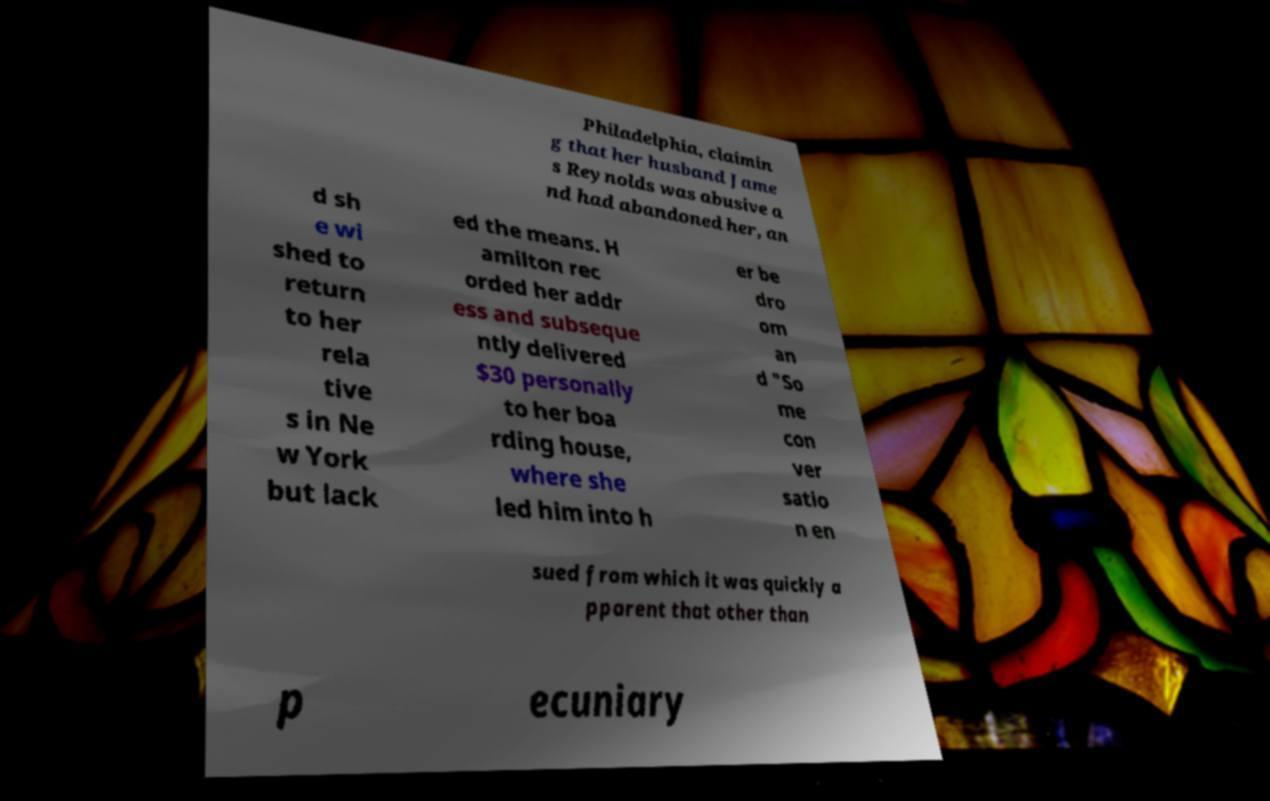What messages or text are displayed in this image? I need them in a readable, typed format. Philadelphia, claimin g that her husband Jame s Reynolds was abusive a nd had abandoned her, an d sh e wi shed to return to her rela tive s in Ne w York but lack ed the means. H amilton rec orded her addr ess and subseque ntly delivered $30 personally to her boa rding house, where she led him into h er be dro om an d "So me con ver satio n en sued from which it was quickly a pparent that other than p ecuniary 